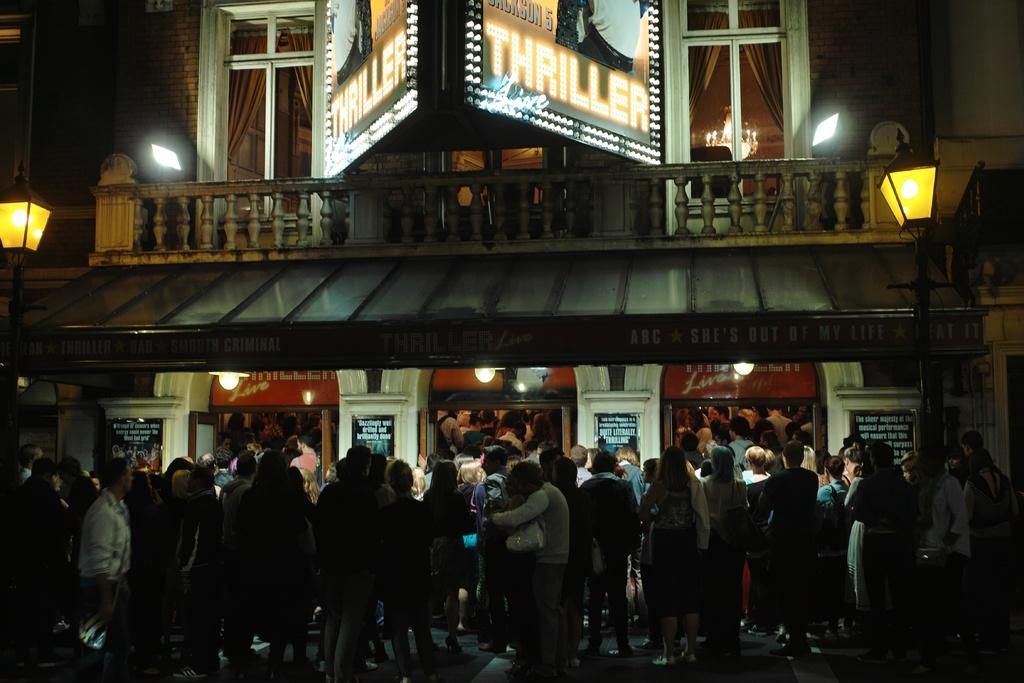What are they seeing?
Give a very brief answer. Thriller. Are they in line to see the movie thriller?
Offer a terse response. Yes. 